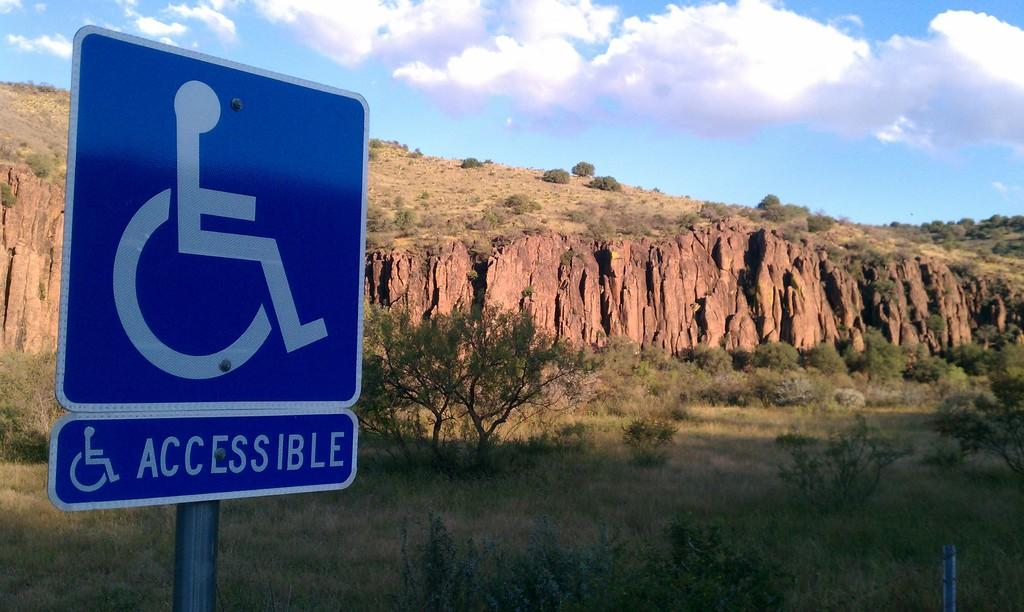<image>
Describe the image concisely. A blue sign says that this area is handicap accessible. 